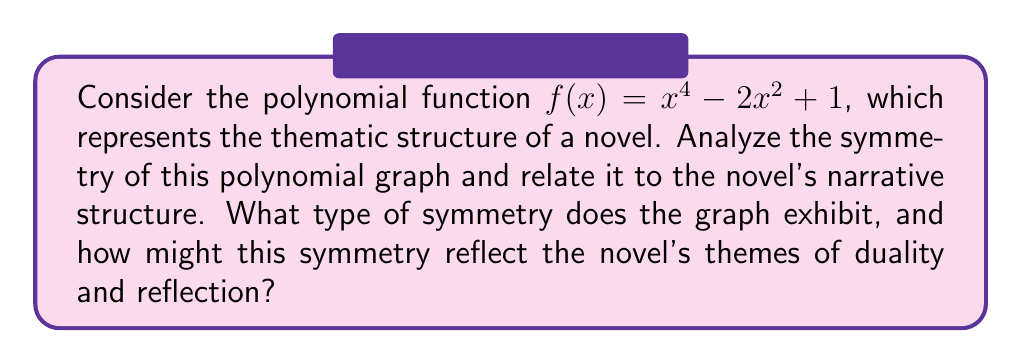Teach me how to tackle this problem. 1) First, let's analyze the polynomial function $f(x) = x^4 - 2x^2 + 1$:

   - This is an even-degree polynomial (degree 4)
   - All terms have even exponents (4, 2, and 0 for the constant term)

2) To determine symmetry, we can check if $f(-x) = f(x)$:

   $f(-x) = (-x)^4 - 2(-x)^2 + 1$
   $= x^4 - 2x^2 + 1$
   $= f(x)$

3) Since $f(-x) = f(x)$, the graph is symmetric about the y-axis.

4) To visualize this symmetry, we can plot key points:

   [asy]
   import graph;
   size(200,200);
   
   real f(real x) {return x^4 - 2x^2 + 1;}
   
   draw(graph(f,-2,2));
   draw((-2,0)--(2,0),arrow=Arrow(TeXHead));
   draw((0,-1)--(0,3),arrow=Arrow(TeXHead));
   
   label("x",(2,0),E);
   label("y",(0,3),N);
   
   dot((0,1));
   dot((1,0));
   dot((-1,0));
   [/asy]

5) Literary interpretation:
   - The y-axis symmetry represents a mirror-like structure in the novel
   - The two minimum points (at x = -1 and x = 1) could represent dual protagonists or conflicting themes
   - The central maximum (at x = 0) might symbolize a pivotal moment or theme that bridges the duality

6) The graph's shape:
   - Resembles a "W" or double-valley
   - Could represent a narrative with two low points and three high points
   - Symmetry suggests a balanced exploration of dual themes or characters

7) This polynomial's symmetry reflects themes of duality and reflection by:
   - Presenting a perfectly mirrored structure
   - Balancing opposing elements (represented by positive and negative x-values)
   - Centering around a focal point (y-axis), which could represent a central theme or event
Answer: Y-axis symmetry; mirrors novel's dual themes and balanced narrative structure 